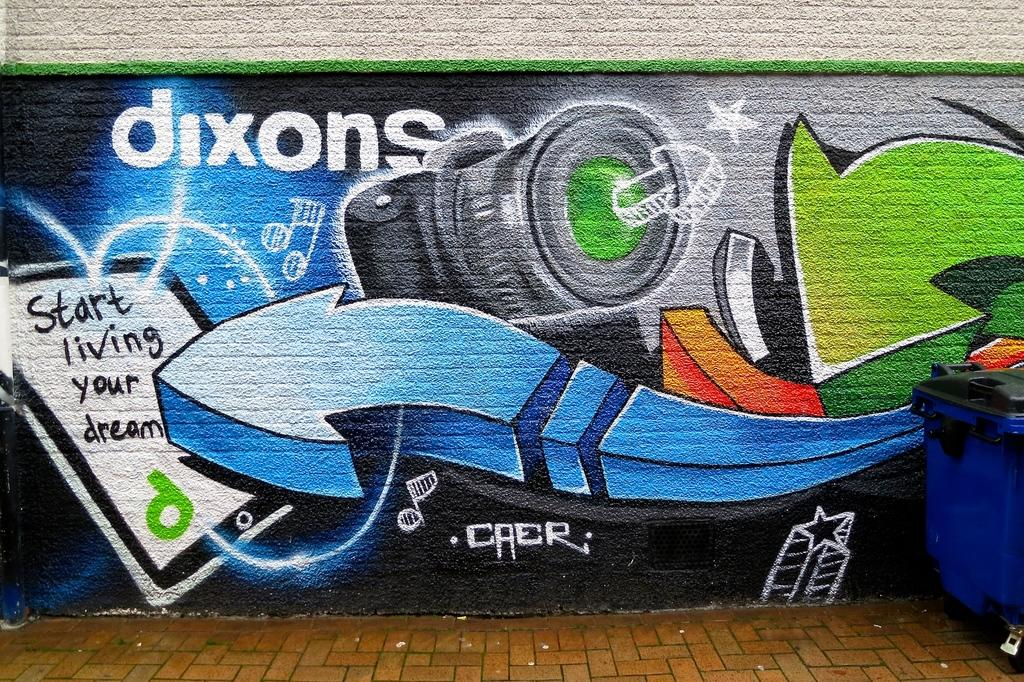<image>
Present a compact description of the photo's key features. Artwork on a brick wall for dixons says to start living your dream. 